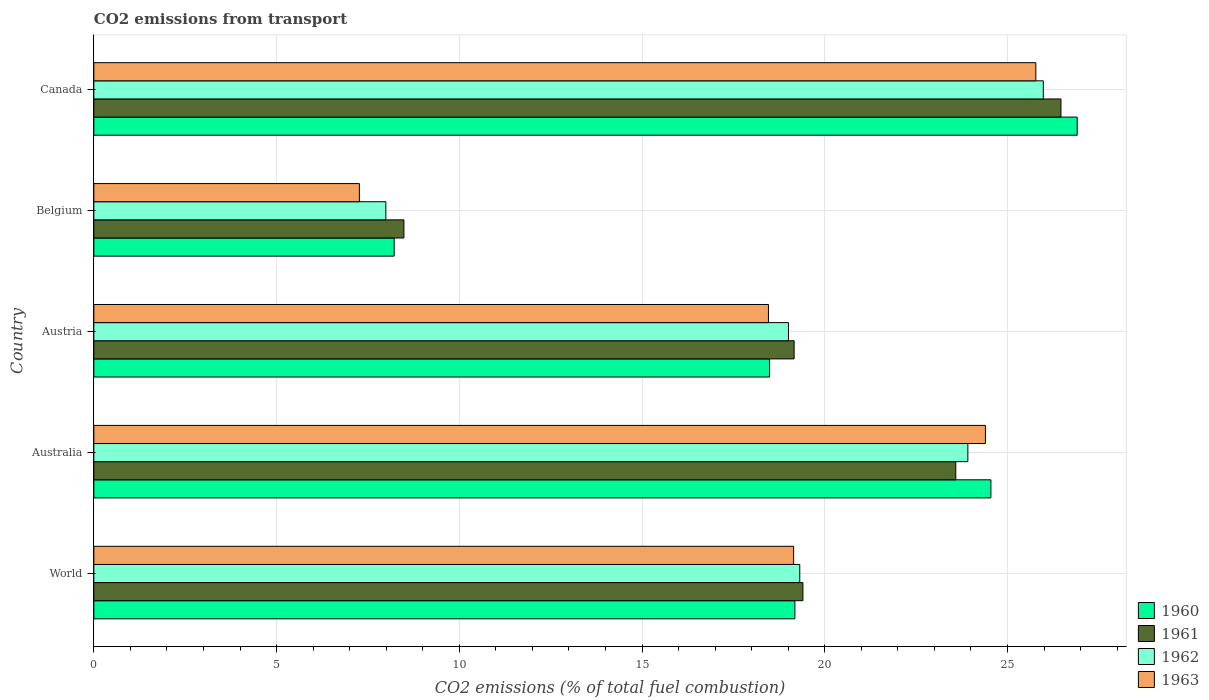How many different coloured bars are there?
Make the answer very short. 4. How many groups of bars are there?
Offer a terse response. 5. Are the number of bars per tick equal to the number of legend labels?
Offer a terse response. Yes. How many bars are there on the 5th tick from the top?
Provide a short and direct response. 4. How many bars are there on the 3rd tick from the bottom?
Your answer should be very brief. 4. What is the label of the 4th group of bars from the top?
Give a very brief answer. Australia. In how many cases, is the number of bars for a given country not equal to the number of legend labels?
Your answer should be very brief. 0. What is the total CO2 emitted in 1963 in World?
Ensure brevity in your answer.  19.15. Across all countries, what is the maximum total CO2 emitted in 1963?
Provide a short and direct response. 25.78. Across all countries, what is the minimum total CO2 emitted in 1962?
Provide a short and direct response. 7.99. What is the total total CO2 emitted in 1960 in the graph?
Provide a short and direct response. 97.35. What is the difference between the total CO2 emitted in 1960 in Canada and that in World?
Keep it short and to the point. 7.72. What is the difference between the total CO2 emitted in 1962 in World and the total CO2 emitted in 1963 in Belgium?
Provide a succinct answer. 12.05. What is the average total CO2 emitted in 1961 per country?
Keep it short and to the point. 19.42. What is the difference between the total CO2 emitted in 1963 and total CO2 emitted in 1962 in Austria?
Your answer should be compact. -0.55. In how many countries, is the total CO2 emitted in 1962 greater than 10 ?
Provide a short and direct response. 4. What is the ratio of the total CO2 emitted in 1962 in Canada to that in World?
Keep it short and to the point. 1.34. Is the total CO2 emitted in 1960 in Austria less than that in Canada?
Ensure brevity in your answer.  Yes. Is the difference between the total CO2 emitted in 1963 in Australia and World greater than the difference between the total CO2 emitted in 1962 in Australia and World?
Provide a short and direct response. Yes. What is the difference between the highest and the second highest total CO2 emitted in 1961?
Provide a short and direct response. 2.88. What is the difference between the highest and the lowest total CO2 emitted in 1961?
Make the answer very short. 17.98. In how many countries, is the total CO2 emitted in 1962 greater than the average total CO2 emitted in 1962 taken over all countries?
Your answer should be compact. 3. What does the 4th bar from the bottom in Austria represents?
Your answer should be compact. 1963. How many bars are there?
Keep it short and to the point. 20. Are all the bars in the graph horizontal?
Your response must be concise. Yes. Does the graph contain any zero values?
Provide a short and direct response. No. How are the legend labels stacked?
Keep it short and to the point. Vertical. What is the title of the graph?
Provide a succinct answer. CO2 emissions from transport. What is the label or title of the X-axis?
Provide a succinct answer. CO2 emissions (% of total fuel combustion). What is the label or title of the Y-axis?
Your response must be concise. Country. What is the CO2 emissions (% of total fuel combustion) of 1960 in World?
Your response must be concise. 19.18. What is the CO2 emissions (% of total fuel combustion) of 1961 in World?
Keep it short and to the point. 19.4. What is the CO2 emissions (% of total fuel combustion) of 1962 in World?
Give a very brief answer. 19.32. What is the CO2 emissions (% of total fuel combustion) of 1963 in World?
Provide a succinct answer. 19.15. What is the CO2 emissions (% of total fuel combustion) in 1960 in Australia?
Ensure brevity in your answer.  24.55. What is the CO2 emissions (% of total fuel combustion) in 1961 in Australia?
Offer a very short reply. 23.59. What is the CO2 emissions (% of total fuel combustion) of 1962 in Australia?
Provide a succinct answer. 23.92. What is the CO2 emissions (% of total fuel combustion) in 1963 in Australia?
Make the answer very short. 24.4. What is the CO2 emissions (% of total fuel combustion) of 1960 in Austria?
Ensure brevity in your answer.  18.49. What is the CO2 emissions (% of total fuel combustion) in 1961 in Austria?
Your answer should be very brief. 19.16. What is the CO2 emissions (% of total fuel combustion) of 1962 in Austria?
Your answer should be compact. 19.01. What is the CO2 emissions (% of total fuel combustion) in 1963 in Austria?
Keep it short and to the point. 18.46. What is the CO2 emissions (% of total fuel combustion) in 1960 in Belgium?
Give a very brief answer. 8.22. What is the CO2 emissions (% of total fuel combustion) of 1961 in Belgium?
Offer a terse response. 8.49. What is the CO2 emissions (% of total fuel combustion) of 1962 in Belgium?
Make the answer very short. 7.99. What is the CO2 emissions (% of total fuel combustion) of 1963 in Belgium?
Offer a very short reply. 7.27. What is the CO2 emissions (% of total fuel combustion) in 1960 in Canada?
Give a very brief answer. 26.91. What is the CO2 emissions (% of total fuel combustion) of 1961 in Canada?
Offer a terse response. 26.46. What is the CO2 emissions (% of total fuel combustion) of 1962 in Canada?
Ensure brevity in your answer.  25.98. What is the CO2 emissions (% of total fuel combustion) of 1963 in Canada?
Your answer should be compact. 25.78. Across all countries, what is the maximum CO2 emissions (% of total fuel combustion) of 1960?
Your answer should be very brief. 26.91. Across all countries, what is the maximum CO2 emissions (% of total fuel combustion) in 1961?
Provide a succinct answer. 26.46. Across all countries, what is the maximum CO2 emissions (% of total fuel combustion) of 1962?
Offer a very short reply. 25.98. Across all countries, what is the maximum CO2 emissions (% of total fuel combustion) of 1963?
Ensure brevity in your answer.  25.78. Across all countries, what is the minimum CO2 emissions (% of total fuel combustion) in 1960?
Provide a short and direct response. 8.22. Across all countries, what is the minimum CO2 emissions (% of total fuel combustion) of 1961?
Make the answer very short. 8.49. Across all countries, what is the minimum CO2 emissions (% of total fuel combustion) in 1962?
Ensure brevity in your answer.  7.99. Across all countries, what is the minimum CO2 emissions (% of total fuel combustion) of 1963?
Make the answer very short. 7.27. What is the total CO2 emissions (% of total fuel combustion) of 1960 in the graph?
Offer a terse response. 97.35. What is the total CO2 emissions (% of total fuel combustion) of 1961 in the graph?
Give a very brief answer. 97.1. What is the total CO2 emissions (% of total fuel combustion) in 1962 in the graph?
Provide a succinct answer. 96.21. What is the total CO2 emissions (% of total fuel combustion) of 1963 in the graph?
Provide a short and direct response. 95.05. What is the difference between the CO2 emissions (% of total fuel combustion) in 1960 in World and that in Australia?
Make the answer very short. -5.36. What is the difference between the CO2 emissions (% of total fuel combustion) of 1961 in World and that in Australia?
Your answer should be very brief. -4.18. What is the difference between the CO2 emissions (% of total fuel combustion) of 1962 in World and that in Australia?
Offer a terse response. -4.6. What is the difference between the CO2 emissions (% of total fuel combustion) in 1963 in World and that in Australia?
Make the answer very short. -5.25. What is the difference between the CO2 emissions (% of total fuel combustion) of 1960 in World and that in Austria?
Your response must be concise. 0.69. What is the difference between the CO2 emissions (% of total fuel combustion) in 1961 in World and that in Austria?
Keep it short and to the point. 0.24. What is the difference between the CO2 emissions (% of total fuel combustion) in 1962 in World and that in Austria?
Your response must be concise. 0.31. What is the difference between the CO2 emissions (% of total fuel combustion) of 1963 in World and that in Austria?
Provide a short and direct response. 0.69. What is the difference between the CO2 emissions (% of total fuel combustion) of 1960 in World and that in Belgium?
Provide a succinct answer. 10.96. What is the difference between the CO2 emissions (% of total fuel combustion) in 1961 in World and that in Belgium?
Your response must be concise. 10.92. What is the difference between the CO2 emissions (% of total fuel combustion) in 1962 in World and that in Belgium?
Your answer should be compact. 11.33. What is the difference between the CO2 emissions (% of total fuel combustion) of 1963 in World and that in Belgium?
Provide a short and direct response. 11.88. What is the difference between the CO2 emissions (% of total fuel combustion) in 1960 in World and that in Canada?
Make the answer very short. -7.72. What is the difference between the CO2 emissions (% of total fuel combustion) in 1961 in World and that in Canada?
Your response must be concise. -7.06. What is the difference between the CO2 emissions (% of total fuel combustion) in 1962 in World and that in Canada?
Give a very brief answer. -6.66. What is the difference between the CO2 emissions (% of total fuel combustion) in 1963 in World and that in Canada?
Your response must be concise. -6.63. What is the difference between the CO2 emissions (% of total fuel combustion) in 1960 in Australia and that in Austria?
Ensure brevity in your answer.  6.06. What is the difference between the CO2 emissions (% of total fuel combustion) in 1961 in Australia and that in Austria?
Provide a short and direct response. 4.42. What is the difference between the CO2 emissions (% of total fuel combustion) of 1962 in Australia and that in Austria?
Give a very brief answer. 4.91. What is the difference between the CO2 emissions (% of total fuel combustion) of 1963 in Australia and that in Austria?
Give a very brief answer. 5.94. What is the difference between the CO2 emissions (% of total fuel combustion) in 1960 in Australia and that in Belgium?
Provide a short and direct response. 16.33. What is the difference between the CO2 emissions (% of total fuel combustion) in 1961 in Australia and that in Belgium?
Your response must be concise. 15.1. What is the difference between the CO2 emissions (% of total fuel combustion) in 1962 in Australia and that in Belgium?
Make the answer very short. 15.93. What is the difference between the CO2 emissions (% of total fuel combustion) of 1963 in Australia and that in Belgium?
Your answer should be very brief. 17.13. What is the difference between the CO2 emissions (% of total fuel combustion) of 1960 in Australia and that in Canada?
Make the answer very short. -2.36. What is the difference between the CO2 emissions (% of total fuel combustion) of 1961 in Australia and that in Canada?
Offer a very short reply. -2.88. What is the difference between the CO2 emissions (% of total fuel combustion) in 1962 in Australia and that in Canada?
Offer a very short reply. -2.06. What is the difference between the CO2 emissions (% of total fuel combustion) in 1963 in Australia and that in Canada?
Ensure brevity in your answer.  -1.38. What is the difference between the CO2 emissions (% of total fuel combustion) in 1960 in Austria and that in Belgium?
Offer a terse response. 10.27. What is the difference between the CO2 emissions (% of total fuel combustion) of 1961 in Austria and that in Belgium?
Your response must be concise. 10.68. What is the difference between the CO2 emissions (% of total fuel combustion) of 1962 in Austria and that in Belgium?
Your answer should be compact. 11.02. What is the difference between the CO2 emissions (% of total fuel combustion) in 1963 in Austria and that in Belgium?
Offer a terse response. 11.19. What is the difference between the CO2 emissions (% of total fuel combustion) of 1960 in Austria and that in Canada?
Make the answer very short. -8.42. What is the difference between the CO2 emissions (% of total fuel combustion) in 1961 in Austria and that in Canada?
Keep it short and to the point. -7.3. What is the difference between the CO2 emissions (% of total fuel combustion) of 1962 in Austria and that in Canada?
Offer a terse response. -6.97. What is the difference between the CO2 emissions (% of total fuel combustion) in 1963 in Austria and that in Canada?
Your answer should be compact. -7.32. What is the difference between the CO2 emissions (% of total fuel combustion) in 1960 in Belgium and that in Canada?
Offer a terse response. -18.69. What is the difference between the CO2 emissions (% of total fuel combustion) of 1961 in Belgium and that in Canada?
Provide a succinct answer. -17.98. What is the difference between the CO2 emissions (% of total fuel combustion) in 1962 in Belgium and that in Canada?
Your answer should be very brief. -17.99. What is the difference between the CO2 emissions (% of total fuel combustion) in 1963 in Belgium and that in Canada?
Keep it short and to the point. -18.51. What is the difference between the CO2 emissions (% of total fuel combustion) in 1960 in World and the CO2 emissions (% of total fuel combustion) in 1961 in Australia?
Keep it short and to the point. -4.4. What is the difference between the CO2 emissions (% of total fuel combustion) of 1960 in World and the CO2 emissions (% of total fuel combustion) of 1962 in Australia?
Provide a succinct answer. -4.73. What is the difference between the CO2 emissions (% of total fuel combustion) in 1960 in World and the CO2 emissions (% of total fuel combustion) in 1963 in Australia?
Provide a succinct answer. -5.21. What is the difference between the CO2 emissions (% of total fuel combustion) of 1961 in World and the CO2 emissions (% of total fuel combustion) of 1962 in Australia?
Offer a very short reply. -4.51. What is the difference between the CO2 emissions (% of total fuel combustion) of 1961 in World and the CO2 emissions (% of total fuel combustion) of 1963 in Australia?
Make the answer very short. -4.99. What is the difference between the CO2 emissions (% of total fuel combustion) of 1962 in World and the CO2 emissions (% of total fuel combustion) of 1963 in Australia?
Make the answer very short. -5.08. What is the difference between the CO2 emissions (% of total fuel combustion) in 1960 in World and the CO2 emissions (% of total fuel combustion) in 1961 in Austria?
Offer a very short reply. 0.02. What is the difference between the CO2 emissions (% of total fuel combustion) of 1960 in World and the CO2 emissions (% of total fuel combustion) of 1962 in Austria?
Offer a terse response. 0.18. What is the difference between the CO2 emissions (% of total fuel combustion) of 1960 in World and the CO2 emissions (% of total fuel combustion) of 1963 in Austria?
Offer a terse response. 0.72. What is the difference between the CO2 emissions (% of total fuel combustion) in 1961 in World and the CO2 emissions (% of total fuel combustion) in 1962 in Austria?
Your response must be concise. 0.4. What is the difference between the CO2 emissions (% of total fuel combustion) of 1961 in World and the CO2 emissions (% of total fuel combustion) of 1963 in Austria?
Offer a terse response. 0.94. What is the difference between the CO2 emissions (% of total fuel combustion) of 1962 in World and the CO2 emissions (% of total fuel combustion) of 1963 in Austria?
Offer a terse response. 0.86. What is the difference between the CO2 emissions (% of total fuel combustion) in 1960 in World and the CO2 emissions (% of total fuel combustion) in 1961 in Belgium?
Your answer should be very brief. 10.7. What is the difference between the CO2 emissions (% of total fuel combustion) in 1960 in World and the CO2 emissions (% of total fuel combustion) in 1962 in Belgium?
Your answer should be very brief. 11.19. What is the difference between the CO2 emissions (% of total fuel combustion) in 1960 in World and the CO2 emissions (% of total fuel combustion) in 1963 in Belgium?
Provide a short and direct response. 11.92. What is the difference between the CO2 emissions (% of total fuel combustion) in 1961 in World and the CO2 emissions (% of total fuel combustion) in 1962 in Belgium?
Ensure brevity in your answer.  11.41. What is the difference between the CO2 emissions (% of total fuel combustion) in 1961 in World and the CO2 emissions (% of total fuel combustion) in 1963 in Belgium?
Make the answer very short. 12.14. What is the difference between the CO2 emissions (% of total fuel combustion) of 1962 in World and the CO2 emissions (% of total fuel combustion) of 1963 in Belgium?
Make the answer very short. 12.05. What is the difference between the CO2 emissions (% of total fuel combustion) in 1960 in World and the CO2 emissions (% of total fuel combustion) in 1961 in Canada?
Make the answer very short. -7.28. What is the difference between the CO2 emissions (% of total fuel combustion) in 1960 in World and the CO2 emissions (% of total fuel combustion) in 1962 in Canada?
Your response must be concise. -6.8. What is the difference between the CO2 emissions (% of total fuel combustion) in 1960 in World and the CO2 emissions (% of total fuel combustion) in 1963 in Canada?
Give a very brief answer. -6.59. What is the difference between the CO2 emissions (% of total fuel combustion) of 1961 in World and the CO2 emissions (% of total fuel combustion) of 1962 in Canada?
Keep it short and to the point. -6.58. What is the difference between the CO2 emissions (% of total fuel combustion) of 1961 in World and the CO2 emissions (% of total fuel combustion) of 1963 in Canada?
Your answer should be very brief. -6.37. What is the difference between the CO2 emissions (% of total fuel combustion) of 1962 in World and the CO2 emissions (% of total fuel combustion) of 1963 in Canada?
Provide a succinct answer. -6.46. What is the difference between the CO2 emissions (% of total fuel combustion) in 1960 in Australia and the CO2 emissions (% of total fuel combustion) in 1961 in Austria?
Your answer should be compact. 5.38. What is the difference between the CO2 emissions (% of total fuel combustion) in 1960 in Australia and the CO2 emissions (% of total fuel combustion) in 1962 in Austria?
Ensure brevity in your answer.  5.54. What is the difference between the CO2 emissions (% of total fuel combustion) of 1960 in Australia and the CO2 emissions (% of total fuel combustion) of 1963 in Austria?
Your answer should be very brief. 6.09. What is the difference between the CO2 emissions (% of total fuel combustion) of 1961 in Australia and the CO2 emissions (% of total fuel combustion) of 1962 in Austria?
Give a very brief answer. 4.58. What is the difference between the CO2 emissions (% of total fuel combustion) in 1961 in Australia and the CO2 emissions (% of total fuel combustion) in 1963 in Austria?
Your answer should be compact. 5.13. What is the difference between the CO2 emissions (% of total fuel combustion) in 1962 in Australia and the CO2 emissions (% of total fuel combustion) in 1963 in Austria?
Give a very brief answer. 5.46. What is the difference between the CO2 emissions (% of total fuel combustion) in 1960 in Australia and the CO2 emissions (% of total fuel combustion) in 1961 in Belgium?
Offer a terse response. 16.06. What is the difference between the CO2 emissions (% of total fuel combustion) of 1960 in Australia and the CO2 emissions (% of total fuel combustion) of 1962 in Belgium?
Keep it short and to the point. 16.56. What is the difference between the CO2 emissions (% of total fuel combustion) of 1960 in Australia and the CO2 emissions (% of total fuel combustion) of 1963 in Belgium?
Offer a very short reply. 17.28. What is the difference between the CO2 emissions (% of total fuel combustion) of 1961 in Australia and the CO2 emissions (% of total fuel combustion) of 1962 in Belgium?
Offer a very short reply. 15.59. What is the difference between the CO2 emissions (% of total fuel combustion) of 1961 in Australia and the CO2 emissions (% of total fuel combustion) of 1963 in Belgium?
Make the answer very short. 16.32. What is the difference between the CO2 emissions (% of total fuel combustion) in 1962 in Australia and the CO2 emissions (% of total fuel combustion) in 1963 in Belgium?
Your answer should be very brief. 16.65. What is the difference between the CO2 emissions (% of total fuel combustion) of 1960 in Australia and the CO2 emissions (% of total fuel combustion) of 1961 in Canada?
Your response must be concise. -1.92. What is the difference between the CO2 emissions (% of total fuel combustion) of 1960 in Australia and the CO2 emissions (% of total fuel combustion) of 1962 in Canada?
Keep it short and to the point. -1.43. What is the difference between the CO2 emissions (% of total fuel combustion) in 1960 in Australia and the CO2 emissions (% of total fuel combustion) in 1963 in Canada?
Keep it short and to the point. -1.23. What is the difference between the CO2 emissions (% of total fuel combustion) in 1961 in Australia and the CO2 emissions (% of total fuel combustion) in 1962 in Canada?
Your answer should be compact. -2.4. What is the difference between the CO2 emissions (% of total fuel combustion) of 1961 in Australia and the CO2 emissions (% of total fuel combustion) of 1963 in Canada?
Make the answer very short. -2.19. What is the difference between the CO2 emissions (% of total fuel combustion) of 1962 in Australia and the CO2 emissions (% of total fuel combustion) of 1963 in Canada?
Provide a succinct answer. -1.86. What is the difference between the CO2 emissions (% of total fuel combustion) of 1960 in Austria and the CO2 emissions (% of total fuel combustion) of 1961 in Belgium?
Make the answer very short. 10. What is the difference between the CO2 emissions (% of total fuel combustion) in 1960 in Austria and the CO2 emissions (% of total fuel combustion) in 1962 in Belgium?
Make the answer very short. 10.5. What is the difference between the CO2 emissions (% of total fuel combustion) in 1960 in Austria and the CO2 emissions (% of total fuel combustion) in 1963 in Belgium?
Your response must be concise. 11.22. What is the difference between the CO2 emissions (% of total fuel combustion) in 1961 in Austria and the CO2 emissions (% of total fuel combustion) in 1962 in Belgium?
Provide a succinct answer. 11.17. What is the difference between the CO2 emissions (% of total fuel combustion) of 1961 in Austria and the CO2 emissions (% of total fuel combustion) of 1963 in Belgium?
Ensure brevity in your answer.  11.9. What is the difference between the CO2 emissions (% of total fuel combustion) of 1962 in Austria and the CO2 emissions (% of total fuel combustion) of 1963 in Belgium?
Provide a short and direct response. 11.74. What is the difference between the CO2 emissions (% of total fuel combustion) in 1960 in Austria and the CO2 emissions (% of total fuel combustion) in 1961 in Canada?
Ensure brevity in your answer.  -7.97. What is the difference between the CO2 emissions (% of total fuel combustion) of 1960 in Austria and the CO2 emissions (% of total fuel combustion) of 1962 in Canada?
Provide a short and direct response. -7.49. What is the difference between the CO2 emissions (% of total fuel combustion) in 1960 in Austria and the CO2 emissions (% of total fuel combustion) in 1963 in Canada?
Make the answer very short. -7.29. What is the difference between the CO2 emissions (% of total fuel combustion) in 1961 in Austria and the CO2 emissions (% of total fuel combustion) in 1962 in Canada?
Provide a succinct answer. -6.82. What is the difference between the CO2 emissions (% of total fuel combustion) of 1961 in Austria and the CO2 emissions (% of total fuel combustion) of 1963 in Canada?
Keep it short and to the point. -6.61. What is the difference between the CO2 emissions (% of total fuel combustion) in 1962 in Austria and the CO2 emissions (% of total fuel combustion) in 1963 in Canada?
Your answer should be compact. -6.77. What is the difference between the CO2 emissions (% of total fuel combustion) in 1960 in Belgium and the CO2 emissions (% of total fuel combustion) in 1961 in Canada?
Provide a short and direct response. -18.25. What is the difference between the CO2 emissions (% of total fuel combustion) of 1960 in Belgium and the CO2 emissions (% of total fuel combustion) of 1962 in Canada?
Give a very brief answer. -17.76. What is the difference between the CO2 emissions (% of total fuel combustion) in 1960 in Belgium and the CO2 emissions (% of total fuel combustion) in 1963 in Canada?
Provide a succinct answer. -17.56. What is the difference between the CO2 emissions (% of total fuel combustion) in 1961 in Belgium and the CO2 emissions (% of total fuel combustion) in 1962 in Canada?
Provide a succinct answer. -17.5. What is the difference between the CO2 emissions (% of total fuel combustion) of 1961 in Belgium and the CO2 emissions (% of total fuel combustion) of 1963 in Canada?
Offer a very short reply. -17.29. What is the difference between the CO2 emissions (% of total fuel combustion) in 1962 in Belgium and the CO2 emissions (% of total fuel combustion) in 1963 in Canada?
Provide a short and direct response. -17.79. What is the average CO2 emissions (% of total fuel combustion) in 1960 per country?
Ensure brevity in your answer.  19.47. What is the average CO2 emissions (% of total fuel combustion) of 1961 per country?
Provide a short and direct response. 19.42. What is the average CO2 emissions (% of total fuel combustion) of 1962 per country?
Make the answer very short. 19.24. What is the average CO2 emissions (% of total fuel combustion) of 1963 per country?
Ensure brevity in your answer.  19.01. What is the difference between the CO2 emissions (% of total fuel combustion) in 1960 and CO2 emissions (% of total fuel combustion) in 1961 in World?
Your answer should be very brief. -0.22. What is the difference between the CO2 emissions (% of total fuel combustion) of 1960 and CO2 emissions (% of total fuel combustion) of 1962 in World?
Keep it short and to the point. -0.13. What is the difference between the CO2 emissions (% of total fuel combustion) of 1960 and CO2 emissions (% of total fuel combustion) of 1963 in World?
Keep it short and to the point. 0.03. What is the difference between the CO2 emissions (% of total fuel combustion) of 1961 and CO2 emissions (% of total fuel combustion) of 1962 in World?
Provide a short and direct response. 0.09. What is the difference between the CO2 emissions (% of total fuel combustion) of 1961 and CO2 emissions (% of total fuel combustion) of 1963 in World?
Your response must be concise. 0.25. What is the difference between the CO2 emissions (% of total fuel combustion) in 1962 and CO2 emissions (% of total fuel combustion) in 1963 in World?
Make the answer very short. 0.17. What is the difference between the CO2 emissions (% of total fuel combustion) in 1960 and CO2 emissions (% of total fuel combustion) in 1961 in Australia?
Offer a very short reply. 0.96. What is the difference between the CO2 emissions (% of total fuel combustion) in 1960 and CO2 emissions (% of total fuel combustion) in 1962 in Australia?
Offer a terse response. 0.63. What is the difference between the CO2 emissions (% of total fuel combustion) of 1960 and CO2 emissions (% of total fuel combustion) of 1963 in Australia?
Your answer should be very brief. 0.15. What is the difference between the CO2 emissions (% of total fuel combustion) in 1961 and CO2 emissions (% of total fuel combustion) in 1962 in Australia?
Offer a terse response. -0.33. What is the difference between the CO2 emissions (% of total fuel combustion) of 1961 and CO2 emissions (% of total fuel combustion) of 1963 in Australia?
Offer a very short reply. -0.81. What is the difference between the CO2 emissions (% of total fuel combustion) in 1962 and CO2 emissions (% of total fuel combustion) in 1963 in Australia?
Your answer should be very brief. -0.48. What is the difference between the CO2 emissions (% of total fuel combustion) in 1960 and CO2 emissions (% of total fuel combustion) in 1961 in Austria?
Your response must be concise. -0.67. What is the difference between the CO2 emissions (% of total fuel combustion) of 1960 and CO2 emissions (% of total fuel combustion) of 1962 in Austria?
Provide a succinct answer. -0.52. What is the difference between the CO2 emissions (% of total fuel combustion) in 1960 and CO2 emissions (% of total fuel combustion) in 1963 in Austria?
Your response must be concise. 0.03. What is the difference between the CO2 emissions (% of total fuel combustion) in 1961 and CO2 emissions (% of total fuel combustion) in 1962 in Austria?
Your answer should be compact. 0.15. What is the difference between the CO2 emissions (% of total fuel combustion) in 1961 and CO2 emissions (% of total fuel combustion) in 1963 in Austria?
Make the answer very short. 0.7. What is the difference between the CO2 emissions (% of total fuel combustion) of 1962 and CO2 emissions (% of total fuel combustion) of 1963 in Austria?
Ensure brevity in your answer.  0.55. What is the difference between the CO2 emissions (% of total fuel combustion) of 1960 and CO2 emissions (% of total fuel combustion) of 1961 in Belgium?
Provide a short and direct response. -0.27. What is the difference between the CO2 emissions (% of total fuel combustion) in 1960 and CO2 emissions (% of total fuel combustion) in 1962 in Belgium?
Ensure brevity in your answer.  0.23. What is the difference between the CO2 emissions (% of total fuel combustion) in 1960 and CO2 emissions (% of total fuel combustion) in 1963 in Belgium?
Ensure brevity in your answer.  0.95. What is the difference between the CO2 emissions (% of total fuel combustion) of 1961 and CO2 emissions (% of total fuel combustion) of 1962 in Belgium?
Give a very brief answer. 0.49. What is the difference between the CO2 emissions (% of total fuel combustion) in 1961 and CO2 emissions (% of total fuel combustion) in 1963 in Belgium?
Provide a succinct answer. 1.22. What is the difference between the CO2 emissions (% of total fuel combustion) in 1962 and CO2 emissions (% of total fuel combustion) in 1963 in Belgium?
Keep it short and to the point. 0.72. What is the difference between the CO2 emissions (% of total fuel combustion) in 1960 and CO2 emissions (% of total fuel combustion) in 1961 in Canada?
Make the answer very short. 0.44. What is the difference between the CO2 emissions (% of total fuel combustion) of 1960 and CO2 emissions (% of total fuel combustion) of 1962 in Canada?
Make the answer very short. 0.93. What is the difference between the CO2 emissions (% of total fuel combustion) of 1960 and CO2 emissions (% of total fuel combustion) of 1963 in Canada?
Provide a short and direct response. 1.13. What is the difference between the CO2 emissions (% of total fuel combustion) of 1961 and CO2 emissions (% of total fuel combustion) of 1962 in Canada?
Provide a short and direct response. 0.48. What is the difference between the CO2 emissions (% of total fuel combustion) of 1961 and CO2 emissions (% of total fuel combustion) of 1963 in Canada?
Make the answer very short. 0.69. What is the difference between the CO2 emissions (% of total fuel combustion) in 1962 and CO2 emissions (% of total fuel combustion) in 1963 in Canada?
Give a very brief answer. 0.2. What is the ratio of the CO2 emissions (% of total fuel combustion) of 1960 in World to that in Australia?
Your answer should be very brief. 0.78. What is the ratio of the CO2 emissions (% of total fuel combustion) of 1961 in World to that in Australia?
Offer a very short reply. 0.82. What is the ratio of the CO2 emissions (% of total fuel combustion) in 1962 in World to that in Australia?
Keep it short and to the point. 0.81. What is the ratio of the CO2 emissions (% of total fuel combustion) of 1963 in World to that in Australia?
Keep it short and to the point. 0.78. What is the ratio of the CO2 emissions (% of total fuel combustion) in 1960 in World to that in Austria?
Make the answer very short. 1.04. What is the ratio of the CO2 emissions (% of total fuel combustion) of 1961 in World to that in Austria?
Provide a short and direct response. 1.01. What is the ratio of the CO2 emissions (% of total fuel combustion) in 1962 in World to that in Austria?
Your answer should be very brief. 1.02. What is the ratio of the CO2 emissions (% of total fuel combustion) of 1963 in World to that in Austria?
Keep it short and to the point. 1.04. What is the ratio of the CO2 emissions (% of total fuel combustion) in 1960 in World to that in Belgium?
Your answer should be very brief. 2.33. What is the ratio of the CO2 emissions (% of total fuel combustion) of 1961 in World to that in Belgium?
Ensure brevity in your answer.  2.29. What is the ratio of the CO2 emissions (% of total fuel combustion) in 1962 in World to that in Belgium?
Keep it short and to the point. 2.42. What is the ratio of the CO2 emissions (% of total fuel combustion) in 1963 in World to that in Belgium?
Keep it short and to the point. 2.64. What is the ratio of the CO2 emissions (% of total fuel combustion) in 1960 in World to that in Canada?
Offer a terse response. 0.71. What is the ratio of the CO2 emissions (% of total fuel combustion) of 1961 in World to that in Canada?
Your response must be concise. 0.73. What is the ratio of the CO2 emissions (% of total fuel combustion) in 1962 in World to that in Canada?
Your answer should be compact. 0.74. What is the ratio of the CO2 emissions (% of total fuel combustion) of 1963 in World to that in Canada?
Provide a succinct answer. 0.74. What is the ratio of the CO2 emissions (% of total fuel combustion) in 1960 in Australia to that in Austria?
Your answer should be very brief. 1.33. What is the ratio of the CO2 emissions (% of total fuel combustion) of 1961 in Australia to that in Austria?
Ensure brevity in your answer.  1.23. What is the ratio of the CO2 emissions (% of total fuel combustion) of 1962 in Australia to that in Austria?
Give a very brief answer. 1.26. What is the ratio of the CO2 emissions (% of total fuel combustion) in 1963 in Australia to that in Austria?
Ensure brevity in your answer.  1.32. What is the ratio of the CO2 emissions (% of total fuel combustion) of 1960 in Australia to that in Belgium?
Offer a very short reply. 2.99. What is the ratio of the CO2 emissions (% of total fuel combustion) of 1961 in Australia to that in Belgium?
Provide a succinct answer. 2.78. What is the ratio of the CO2 emissions (% of total fuel combustion) of 1962 in Australia to that in Belgium?
Your response must be concise. 2.99. What is the ratio of the CO2 emissions (% of total fuel combustion) in 1963 in Australia to that in Belgium?
Ensure brevity in your answer.  3.36. What is the ratio of the CO2 emissions (% of total fuel combustion) of 1960 in Australia to that in Canada?
Your answer should be compact. 0.91. What is the ratio of the CO2 emissions (% of total fuel combustion) in 1961 in Australia to that in Canada?
Provide a short and direct response. 0.89. What is the ratio of the CO2 emissions (% of total fuel combustion) in 1962 in Australia to that in Canada?
Make the answer very short. 0.92. What is the ratio of the CO2 emissions (% of total fuel combustion) of 1963 in Australia to that in Canada?
Keep it short and to the point. 0.95. What is the ratio of the CO2 emissions (% of total fuel combustion) of 1960 in Austria to that in Belgium?
Offer a very short reply. 2.25. What is the ratio of the CO2 emissions (% of total fuel combustion) of 1961 in Austria to that in Belgium?
Your answer should be very brief. 2.26. What is the ratio of the CO2 emissions (% of total fuel combustion) of 1962 in Austria to that in Belgium?
Ensure brevity in your answer.  2.38. What is the ratio of the CO2 emissions (% of total fuel combustion) in 1963 in Austria to that in Belgium?
Make the answer very short. 2.54. What is the ratio of the CO2 emissions (% of total fuel combustion) of 1960 in Austria to that in Canada?
Your response must be concise. 0.69. What is the ratio of the CO2 emissions (% of total fuel combustion) of 1961 in Austria to that in Canada?
Provide a short and direct response. 0.72. What is the ratio of the CO2 emissions (% of total fuel combustion) in 1962 in Austria to that in Canada?
Your response must be concise. 0.73. What is the ratio of the CO2 emissions (% of total fuel combustion) in 1963 in Austria to that in Canada?
Keep it short and to the point. 0.72. What is the ratio of the CO2 emissions (% of total fuel combustion) of 1960 in Belgium to that in Canada?
Offer a terse response. 0.31. What is the ratio of the CO2 emissions (% of total fuel combustion) in 1961 in Belgium to that in Canada?
Ensure brevity in your answer.  0.32. What is the ratio of the CO2 emissions (% of total fuel combustion) of 1962 in Belgium to that in Canada?
Make the answer very short. 0.31. What is the ratio of the CO2 emissions (% of total fuel combustion) of 1963 in Belgium to that in Canada?
Your answer should be very brief. 0.28. What is the difference between the highest and the second highest CO2 emissions (% of total fuel combustion) of 1960?
Ensure brevity in your answer.  2.36. What is the difference between the highest and the second highest CO2 emissions (% of total fuel combustion) of 1961?
Provide a short and direct response. 2.88. What is the difference between the highest and the second highest CO2 emissions (% of total fuel combustion) in 1962?
Provide a short and direct response. 2.06. What is the difference between the highest and the second highest CO2 emissions (% of total fuel combustion) of 1963?
Ensure brevity in your answer.  1.38. What is the difference between the highest and the lowest CO2 emissions (% of total fuel combustion) of 1960?
Give a very brief answer. 18.69. What is the difference between the highest and the lowest CO2 emissions (% of total fuel combustion) in 1961?
Your answer should be compact. 17.98. What is the difference between the highest and the lowest CO2 emissions (% of total fuel combustion) of 1962?
Ensure brevity in your answer.  17.99. What is the difference between the highest and the lowest CO2 emissions (% of total fuel combustion) in 1963?
Your answer should be very brief. 18.51. 